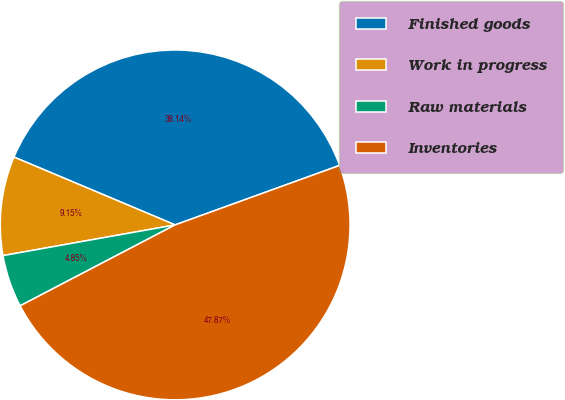Convert chart to OTSL. <chart><loc_0><loc_0><loc_500><loc_500><pie_chart><fcel>Finished goods<fcel>Work in progress<fcel>Raw materials<fcel>Inventories<nl><fcel>38.14%<fcel>9.15%<fcel>4.85%<fcel>47.87%<nl></chart> 